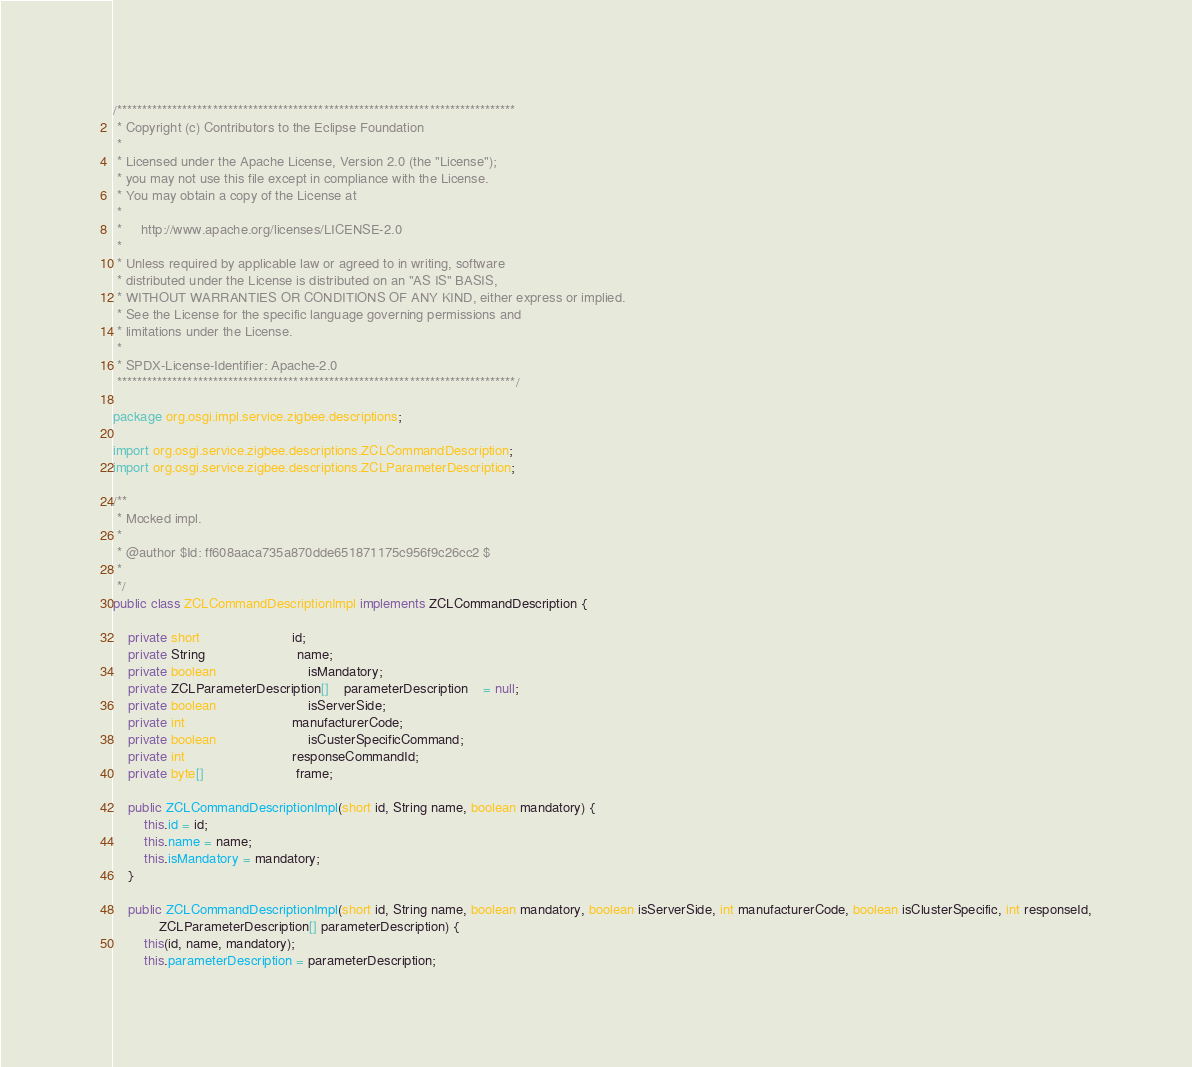<code> <loc_0><loc_0><loc_500><loc_500><_Java_>/*******************************************************************************
 * Copyright (c) Contributors to the Eclipse Foundation
 *
 * Licensed under the Apache License, Version 2.0 (the "License");
 * you may not use this file except in compliance with the License.
 * You may obtain a copy of the License at
 *
 *     http://www.apache.org/licenses/LICENSE-2.0
 *
 * Unless required by applicable law or agreed to in writing, software
 * distributed under the License is distributed on an "AS IS" BASIS,
 * WITHOUT WARRANTIES OR CONDITIONS OF ANY KIND, either express or implied.
 * See the License for the specific language governing permissions and
 * limitations under the License.
 *
 * SPDX-License-Identifier: Apache-2.0 
 *******************************************************************************/

package org.osgi.impl.service.zigbee.descriptions;

import org.osgi.service.zigbee.descriptions.ZCLCommandDescription;
import org.osgi.service.zigbee.descriptions.ZCLParameterDescription;

/**
 * Mocked impl.
 * 
 * @author $Id: ff608aaca735a870dde651871175c956f9c26cc2 $
 * 
 */
public class ZCLCommandDescriptionImpl implements ZCLCommandDescription {

	private short						id;
	private String						name;
	private boolean						isMandatory;
	private ZCLParameterDescription[]	parameterDescription	= null;
	private boolean						isServerSide;
	private int							manufacturerCode;
	private boolean						isCusterSpecificCommand;
	private int							responseCommandId;
	private byte[]						frame;

	public ZCLCommandDescriptionImpl(short id, String name, boolean mandatory) {
		this.id = id;
		this.name = name;
		this.isMandatory = mandatory;
	}

	public ZCLCommandDescriptionImpl(short id, String name, boolean mandatory, boolean isServerSide, int manufacturerCode, boolean isClusterSpecific, int responseId,
			ZCLParameterDescription[] parameterDescription) {
		this(id, name, mandatory);
		this.parameterDescription = parameterDescription;</code> 